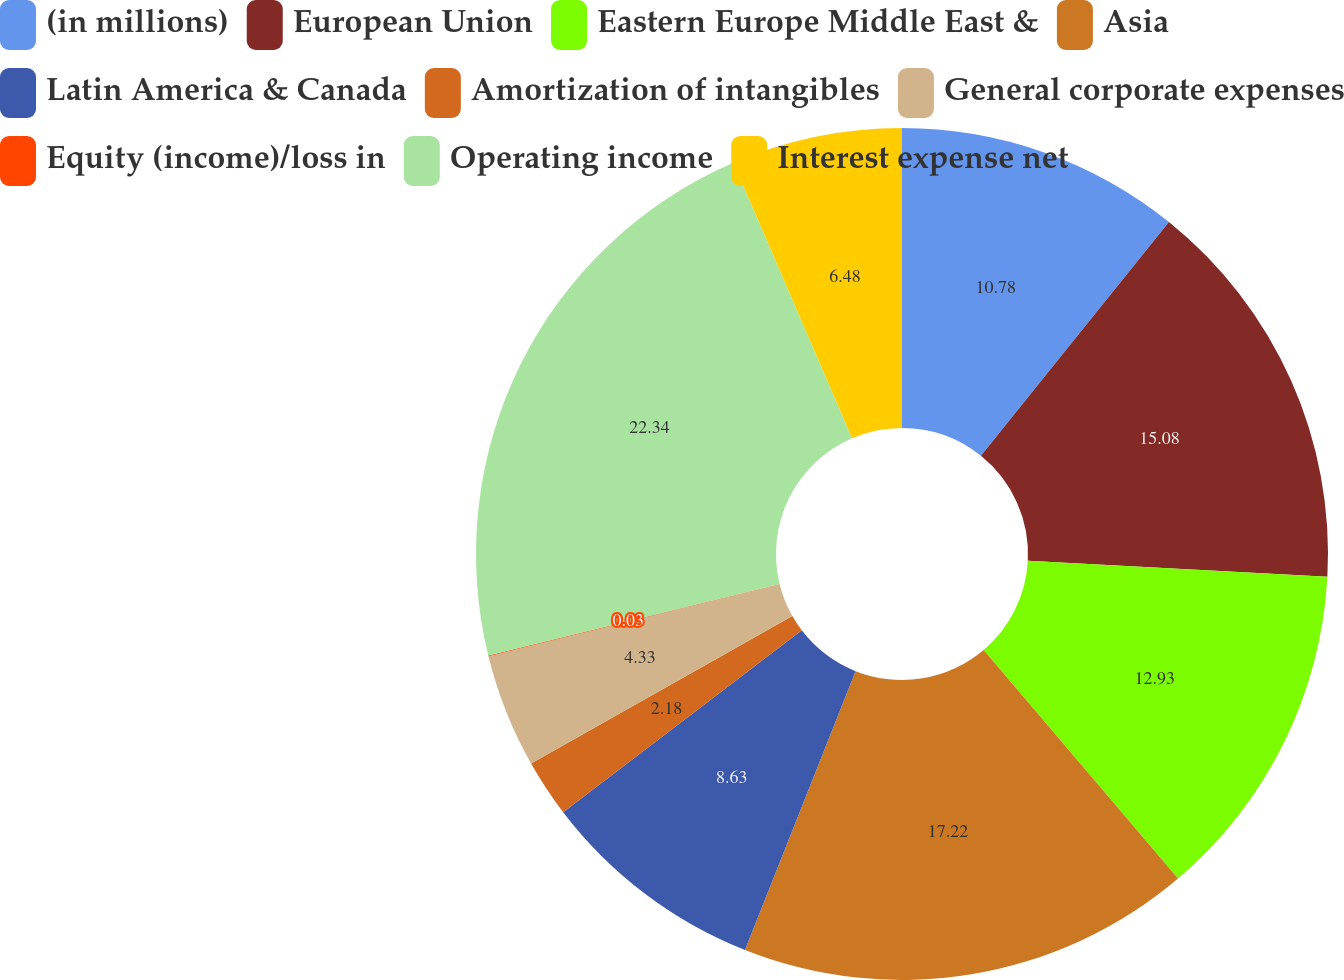<chart> <loc_0><loc_0><loc_500><loc_500><pie_chart><fcel>(in millions)<fcel>European Union<fcel>Eastern Europe Middle East &<fcel>Asia<fcel>Latin America & Canada<fcel>Amortization of intangibles<fcel>General corporate expenses<fcel>Equity (income)/loss in<fcel>Operating income<fcel>Interest expense net<nl><fcel>10.78%<fcel>15.08%<fcel>12.93%<fcel>17.23%<fcel>8.63%<fcel>2.18%<fcel>4.33%<fcel>0.03%<fcel>22.35%<fcel>6.48%<nl></chart> 